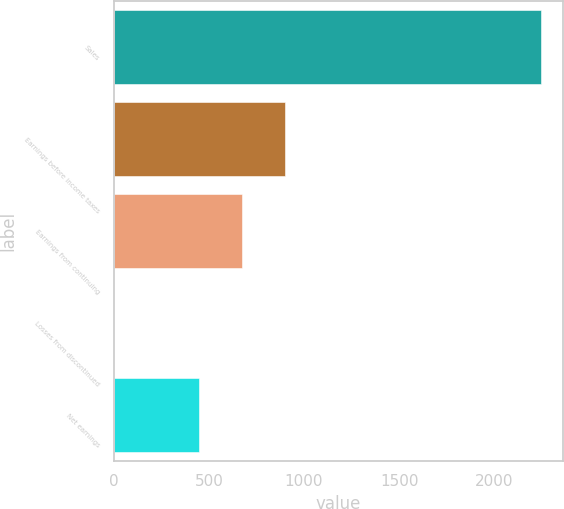<chart> <loc_0><loc_0><loc_500><loc_500><bar_chart><fcel>Sales<fcel>Earnings before income taxes<fcel>Earnings from continuing<fcel>Losses from discontinued<fcel>Net earnings<nl><fcel>2246.5<fcel>898.62<fcel>673.97<fcel>0.02<fcel>449.32<nl></chart> 